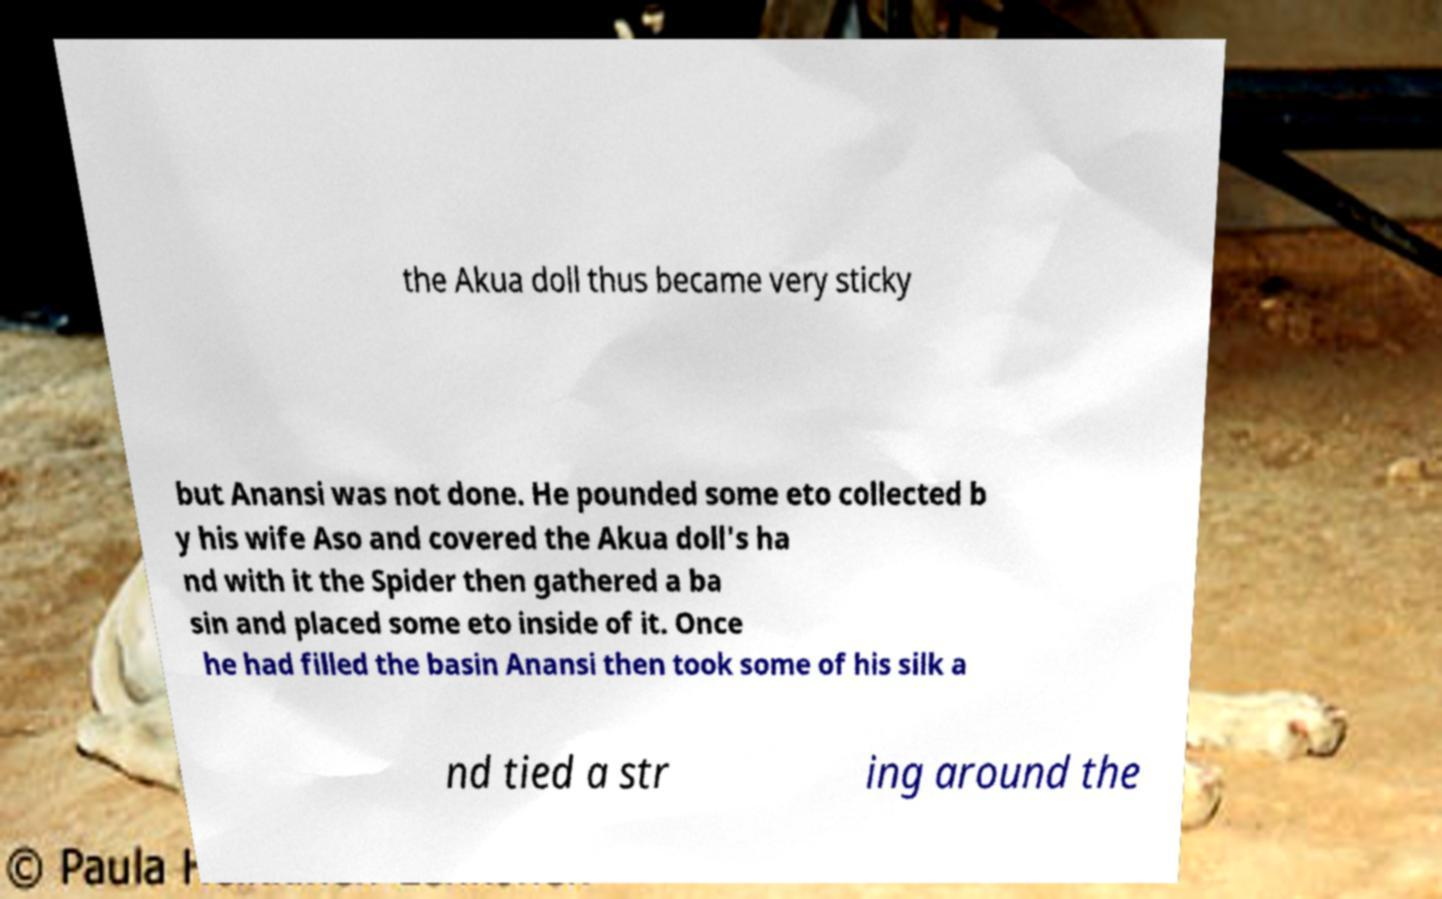Could you assist in decoding the text presented in this image and type it out clearly? the Akua doll thus became very sticky but Anansi was not done. He pounded some eto collected b y his wife Aso and covered the Akua doll's ha nd with it the Spider then gathered a ba sin and placed some eto inside of it. Once he had filled the basin Anansi then took some of his silk a nd tied a str ing around the 